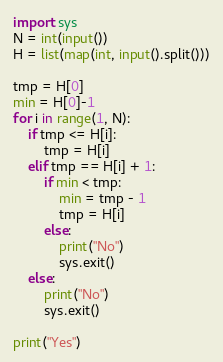<code> <loc_0><loc_0><loc_500><loc_500><_Python_>import sys
N = int(input())
H = list(map(int, input().split()))

tmp = H[0]
min = H[0]-1
for i in range(1, N):
    if tmp <= H[i]:
        tmp = H[i]
    elif tmp == H[i] + 1:
        if min < tmp:
            min = tmp - 1
            tmp = H[i]
        else:
            print("No")
            sys.exit()
    else:
        print("No")
        sys.exit()

print("Yes")

</code> 